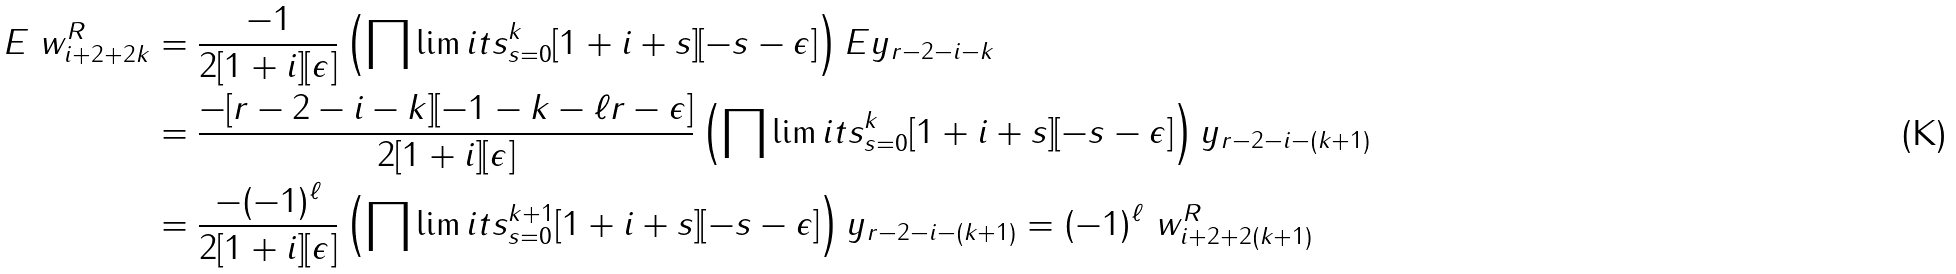<formula> <loc_0><loc_0><loc_500><loc_500>E \ w _ { i + 2 + 2 k } ^ { R } & = \frac { - 1 } { 2 [ 1 + i ] [ \epsilon ] } \left ( \prod \lim i t s _ { s = 0 } ^ { k } [ 1 + i + s ] [ - s - \epsilon ] \right ) E y _ { r - 2 - i - k } \\ & = \frac { - [ r - 2 - i - k ] [ - 1 - k - \ell r - \epsilon ] } { 2 [ 1 + i ] [ \epsilon ] } \left ( \prod \lim i t s _ { s = 0 } ^ { k } [ 1 + i + s ] [ - s - \epsilon ] \right ) y _ { r - 2 - i - ( k + 1 ) } \\ & = \frac { - ( - 1 ) ^ { \ell } } { 2 [ 1 + i ] [ \epsilon ] } \left ( \prod \lim i t s _ { s = 0 } ^ { k + 1 } [ 1 + i + s ] [ - s - \epsilon ] \right ) y _ { r - 2 - i - ( k + 1 ) } = ( - 1 ) ^ { \ell } \ w _ { i + 2 + 2 ( k + 1 ) } ^ { R }</formula> 